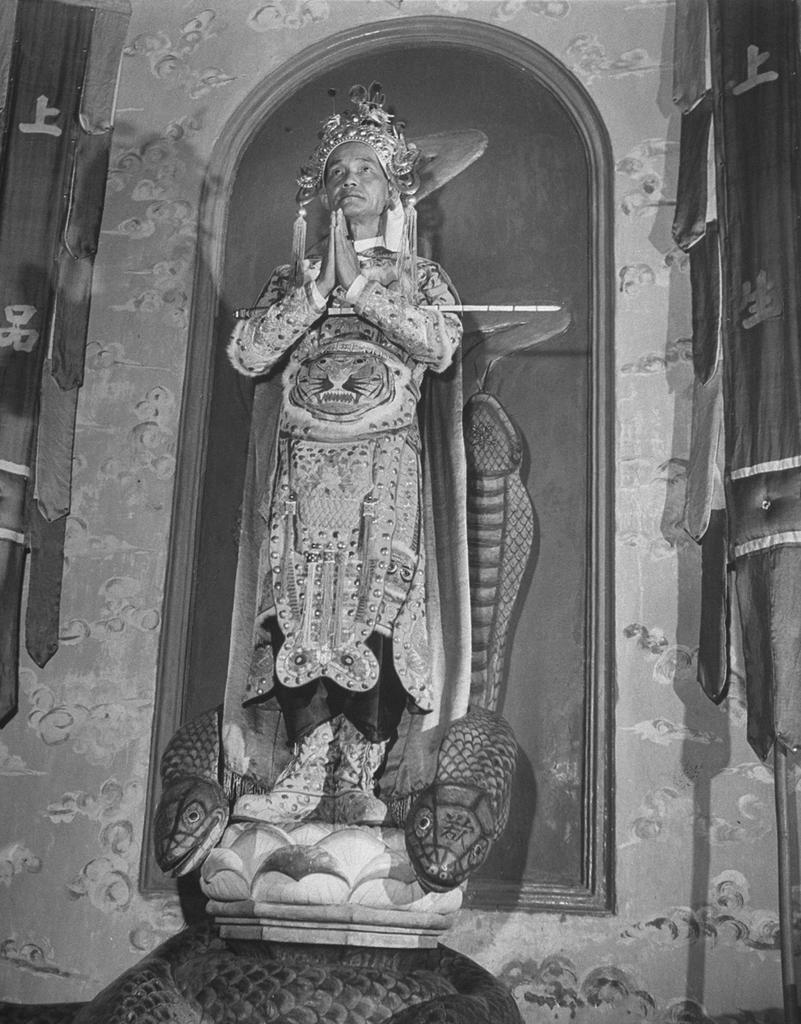What is the main subject of the image? There is a man standing in the center of the image. What is the man wearing in the image? The man is wearing a costume in the image. What can be seen in the background of the image? There is a wall and curtains in the background of the image. What type of shoes is the man wearing in the image? The provided facts do not mention any shoes, so we cannot determine the type of shoes the man is wearing in the image. 